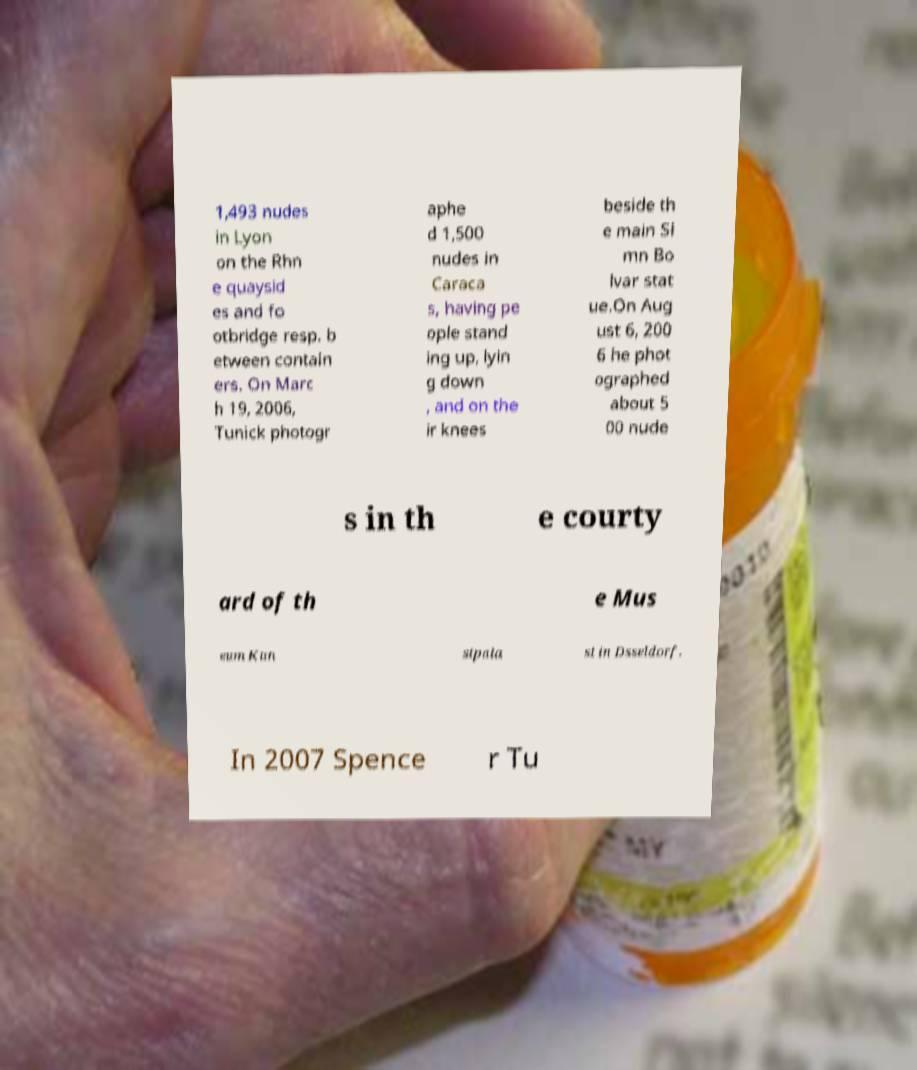Could you extract and type out the text from this image? 1,493 nudes in Lyon on the Rhn e quaysid es and fo otbridge resp. b etween contain ers. On Marc h 19, 2006, Tunick photogr aphe d 1,500 nudes in Caraca s, having pe ople stand ing up, lyin g down , and on the ir knees beside th e main Si mn Bo lvar stat ue.On Aug ust 6, 200 6 he phot ographed about 5 00 nude s in th e courty ard of th e Mus eum Kun stpala st in Dsseldorf. In 2007 Spence r Tu 